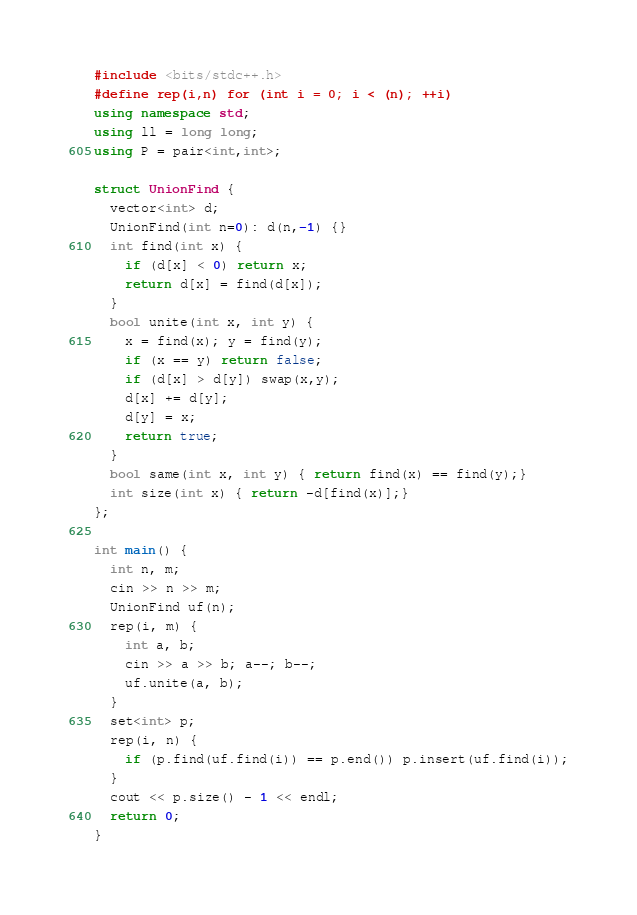Convert code to text. <code><loc_0><loc_0><loc_500><loc_500><_C++_>#include <bits/stdc++.h>
#define rep(i,n) for (int i = 0; i < (n); ++i)
using namespace std;
using ll = long long;
using P = pair<int,int>;

struct UnionFind {
  vector<int> d;
  UnionFind(int n=0): d(n,-1) {}
  int find(int x) {
    if (d[x] < 0) return x;
    return d[x] = find(d[x]);
  }
  bool unite(int x, int y) {
    x = find(x); y = find(y);
    if (x == y) return false;
    if (d[x] > d[y]) swap(x,y);
    d[x] += d[y];
    d[y] = x;
    return true;
  }
  bool same(int x, int y) { return find(x) == find(y);}
  int size(int x) { return -d[find(x)];}
};

int main() {
  int n, m;
  cin >> n >> m;
  UnionFind uf(n);
  rep(i, m) {
    int a, b;
    cin >> a >> b; a--; b--;
    uf.unite(a, b);
  }
  set<int> p;
  rep(i, n) {
    if (p.find(uf.find(i)) == p.end()) p.insert(uf.find(i));
  }
  cout << p.size() - 1 << endl;
  return 0;
}</code> 